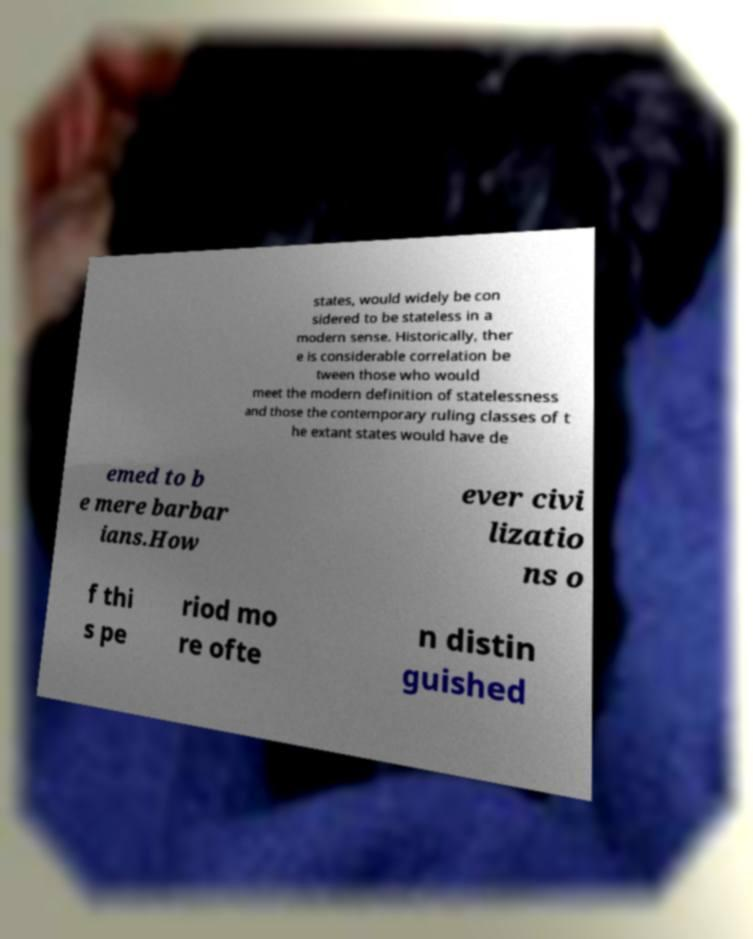Could you extract and type out the text from this image? states, would widely be con sidered to be stateless in a modern sense. Historically, ther e is considerable correlation be tween those who would meet the modern definition of statelessness and those the contemporary ruling classes of t he extant states would have de emed to b e mere barbar ians.How ever civi lizatio ns o f thi s pe riod mo re ofte n distin guished 